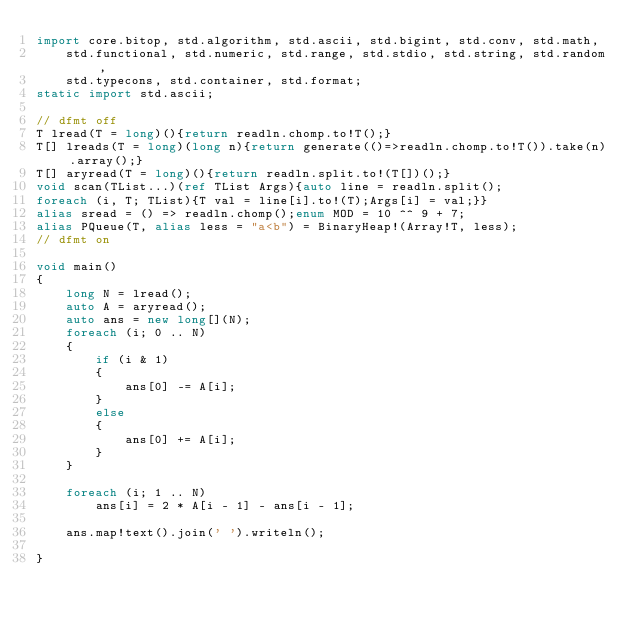Convert code to text. <code><loc_0><loc_0><loc_500><loc_500><_D_>import core.bitop, std.algorithm, std.ascii, std.bigint, std.conv, std.math,
    std.functional, std.numeric, std.range, std.stdio, std.string, std.random,
    std.typecons, std.container, std.format;
static import std.ascii;

// dfmt off
T lread(T = long)(){return readln.chomp.to!T();}
T[] lreads(T = long)(long n){return generate(()=>readln.chomp.to!T()).take(n).array();}
T[] aryread(T = long)(){return readln.split.to!(T[])();}
void scan(TList...)(ref TList Args){auto line = readln.split();
foreach (i, T; TList){T val = line[i].to!(T);Args[i] = val;}}
alias sread = () => readln.chomp();enum MOD = 10 ^^ 9 + 7;
alias PQueue(T, alias less = "a<b") = BinaryHeap!(Array!T, less);
// dfmt on

void main()
{
    long N = lread();
    auto A = aryread();
    auto ans = new long[](N);
    foreach (i; 0 .. N)
    {
        if (i & 1)
        {
            ans[0] -= A[i];
        }
        else
        {
            ans[0] += A[i];
        }
    }

    foreach (i; 1 .. N)
        ans[i] = 2 * A[i - 1] - ans[i - 1];

    ans.map!text().join(' ').writeln();

}
</code> 